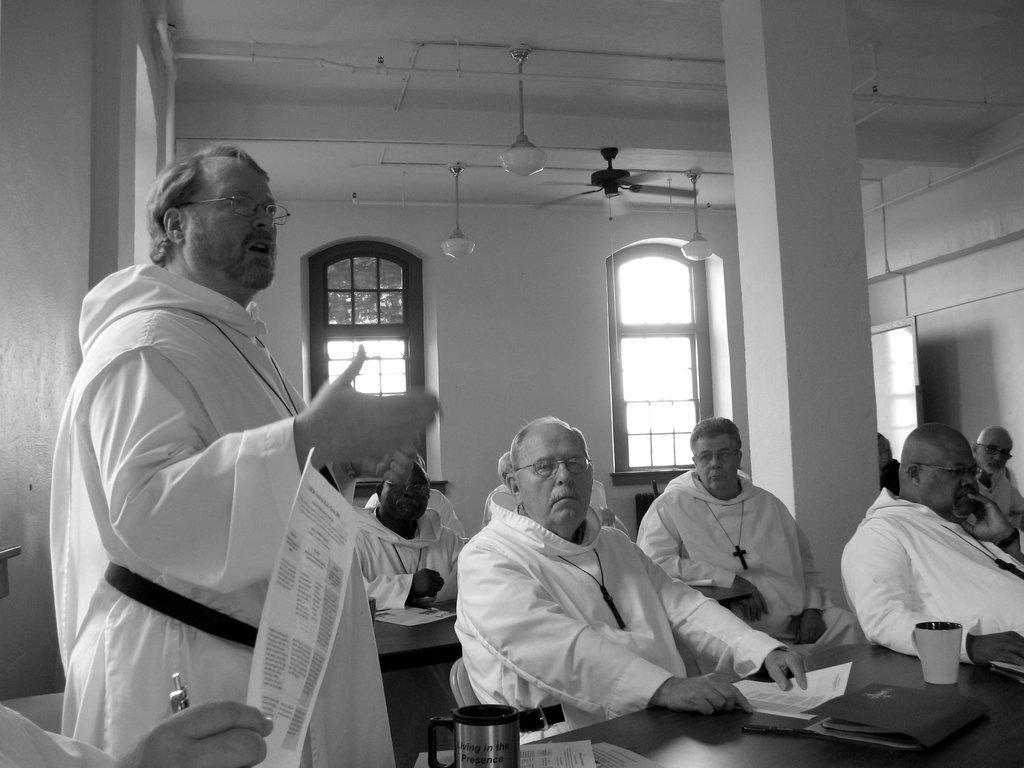How would you summarize this image in a sentence or two? In this image there is a wall on the left corner. There are people, chairs, tables with cups and objects on it in the foreground. There is a pillar, wall and there are windows in the background. There is roof at the top. 